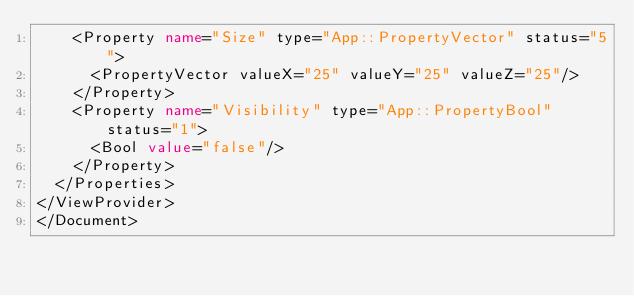Convert code to text. <code><loc_0><loc_0><loc_500><loc_500><_XML_>    <Property name="Size" type="App::PropertyVector" status="5">
      <PropertyVector valueX="25" valueY="25" valueZ="25"/>
    </Property>
    <Property name="Visibility" type="App::PropertyBool" status="1">
      <Bool value="false"/>
    </Property>
  </Properties>
</ViewProvider>
</Document>
</code> 